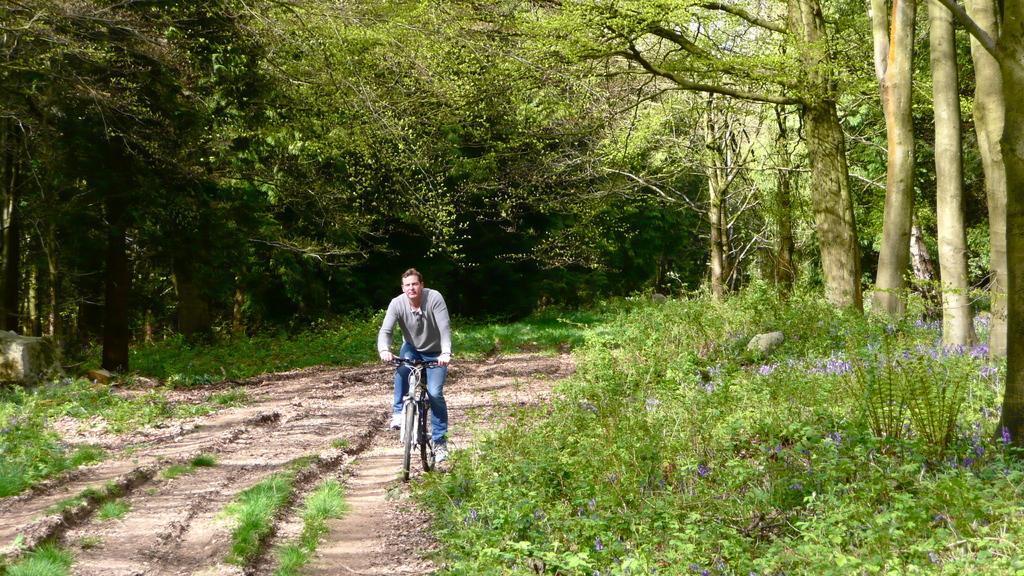Can you describe this image briefly? In this image a man is riding a bicycle. In the background there are trees. On the ground there are plants. 